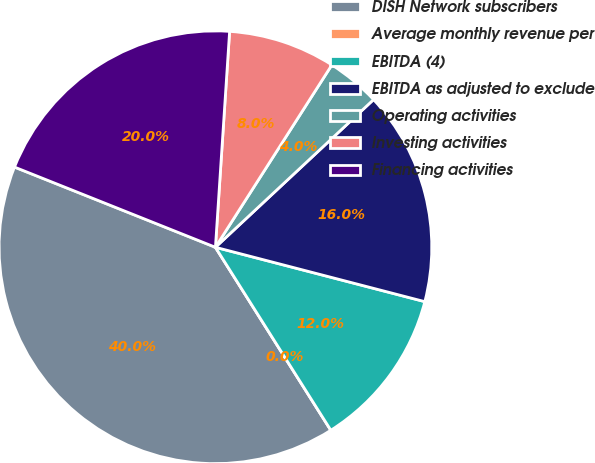<chart> <loc_0><loc_0><loc_500><loc_500><pie_chart><fcel>DISH Network subscribers<fcel>Average monthly revenue per<fcel>EBITDA (4)<fcel>EBITDA as adjusted to exclude<fcel>Operating activities<fcel>Investing activities<fcel>Financing activities<nl><fcel>40.0%<fcel>0.0%<fcel>12.0%<fcel>16.0%<fcel>4.0%<fcel>8.0%<fcel>20.0%<nl></chart> 